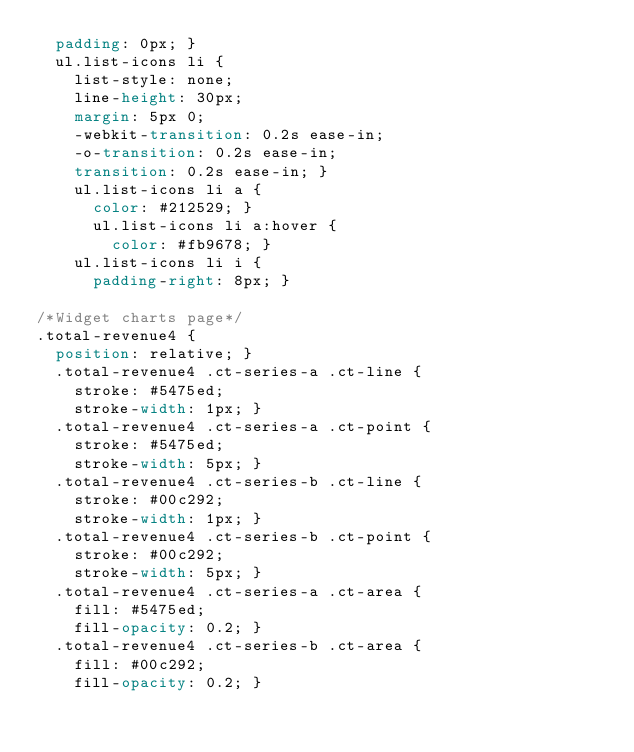<code> <loc_0><loc_0><loc_500><loc_500><_CSS_>  padding: 0px; }
  ul.list-icons li {
    list-style: none;
    line-height: 30px;
    margin: 5px 0;
    -webkit-transition: 0.2s ease-in;
    -o-transition: 0.2s ease-in;
    transition: 0.2s ease-in; }
    ul.list-icons li a {
      color: #212529; }
      ul.list-icons li a:hover {
        color: #fb9678; }
    ul.list-icons li i {
      padding-right: 8px; }

/*Widget charts page*/
.total-revenue4 {
  position: relative; }
  .total-revenue4 .ct-series-a .ct-line {
    stroke: #5475ed;
    stroke-width: 1px; }
  .total-revenue4 .ct-series-a .ct-point {
    stroke: #5475ed;
    stroke-width: 5px; }
  .total-revenue4 .ct-series-b .ct-line {
    stroke: #00c292;
    stroke-width: 1px; }
  .total-revenue4 .ct-series-b .ct-point {
    stroke: #00c292;
    stroke-width: 5px; }
  .total-revenue4 .ct-series-a .ct-area {
    fill: #5475ed;
    fill-opacity: 0.2; }
  .total-revenue4 .ct-series-b .ct-area {
    fill: #00c292;
    fill-opacity: 0.2; }
</code> 